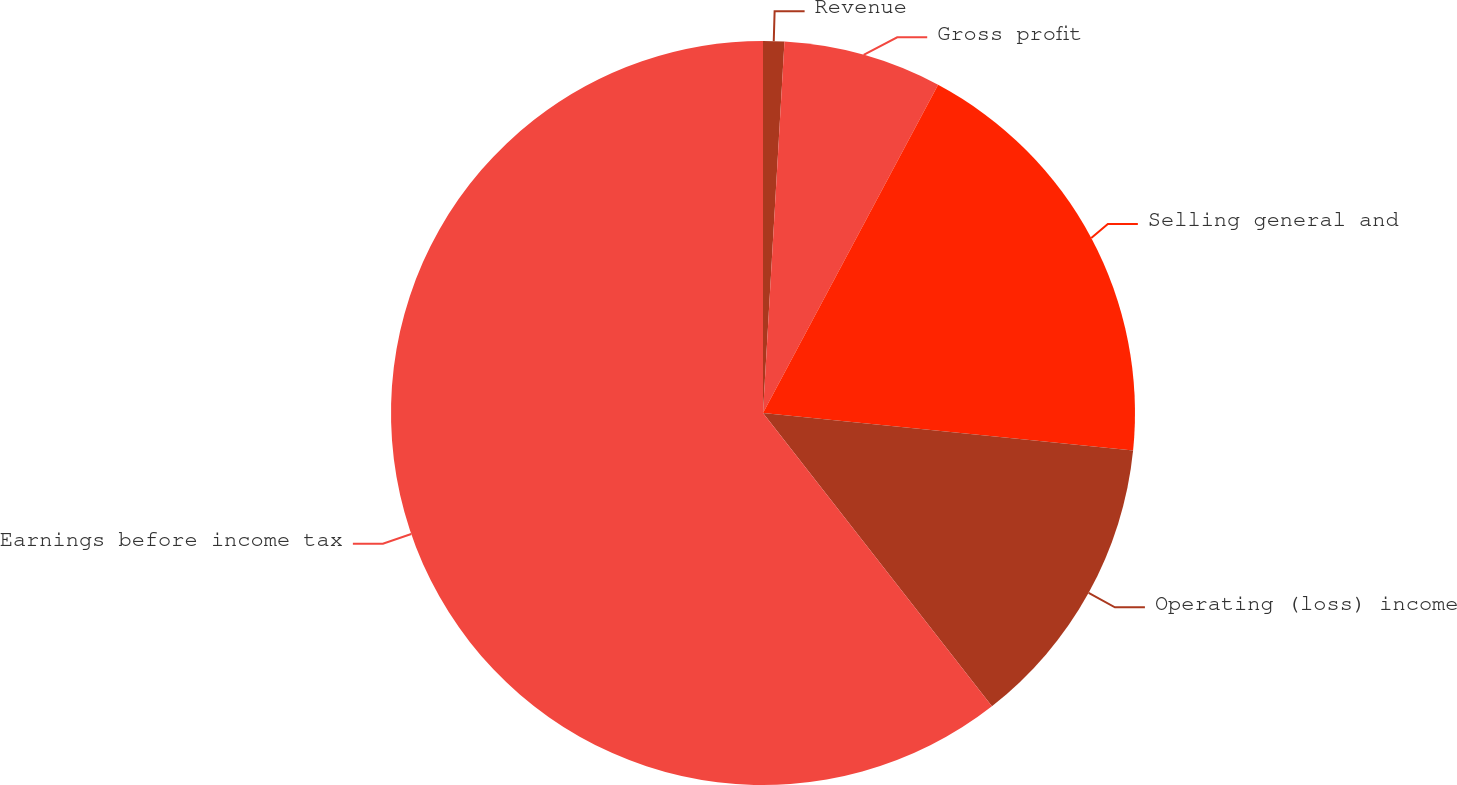Convert chart to OTSL. <chart><loc_0><loc_0><loc_500><loc_500><pie_chart><fcel>Revenue<fcel>Gross profit<fcel>Selling general and<fcel>Operating (loss) income<fcel>Earnings before income tax<nl><fcel>0.92%<fcel>6.88%<fcel>18.81%<fcel>12.84%<fcel>60.55%<nl></chart> 